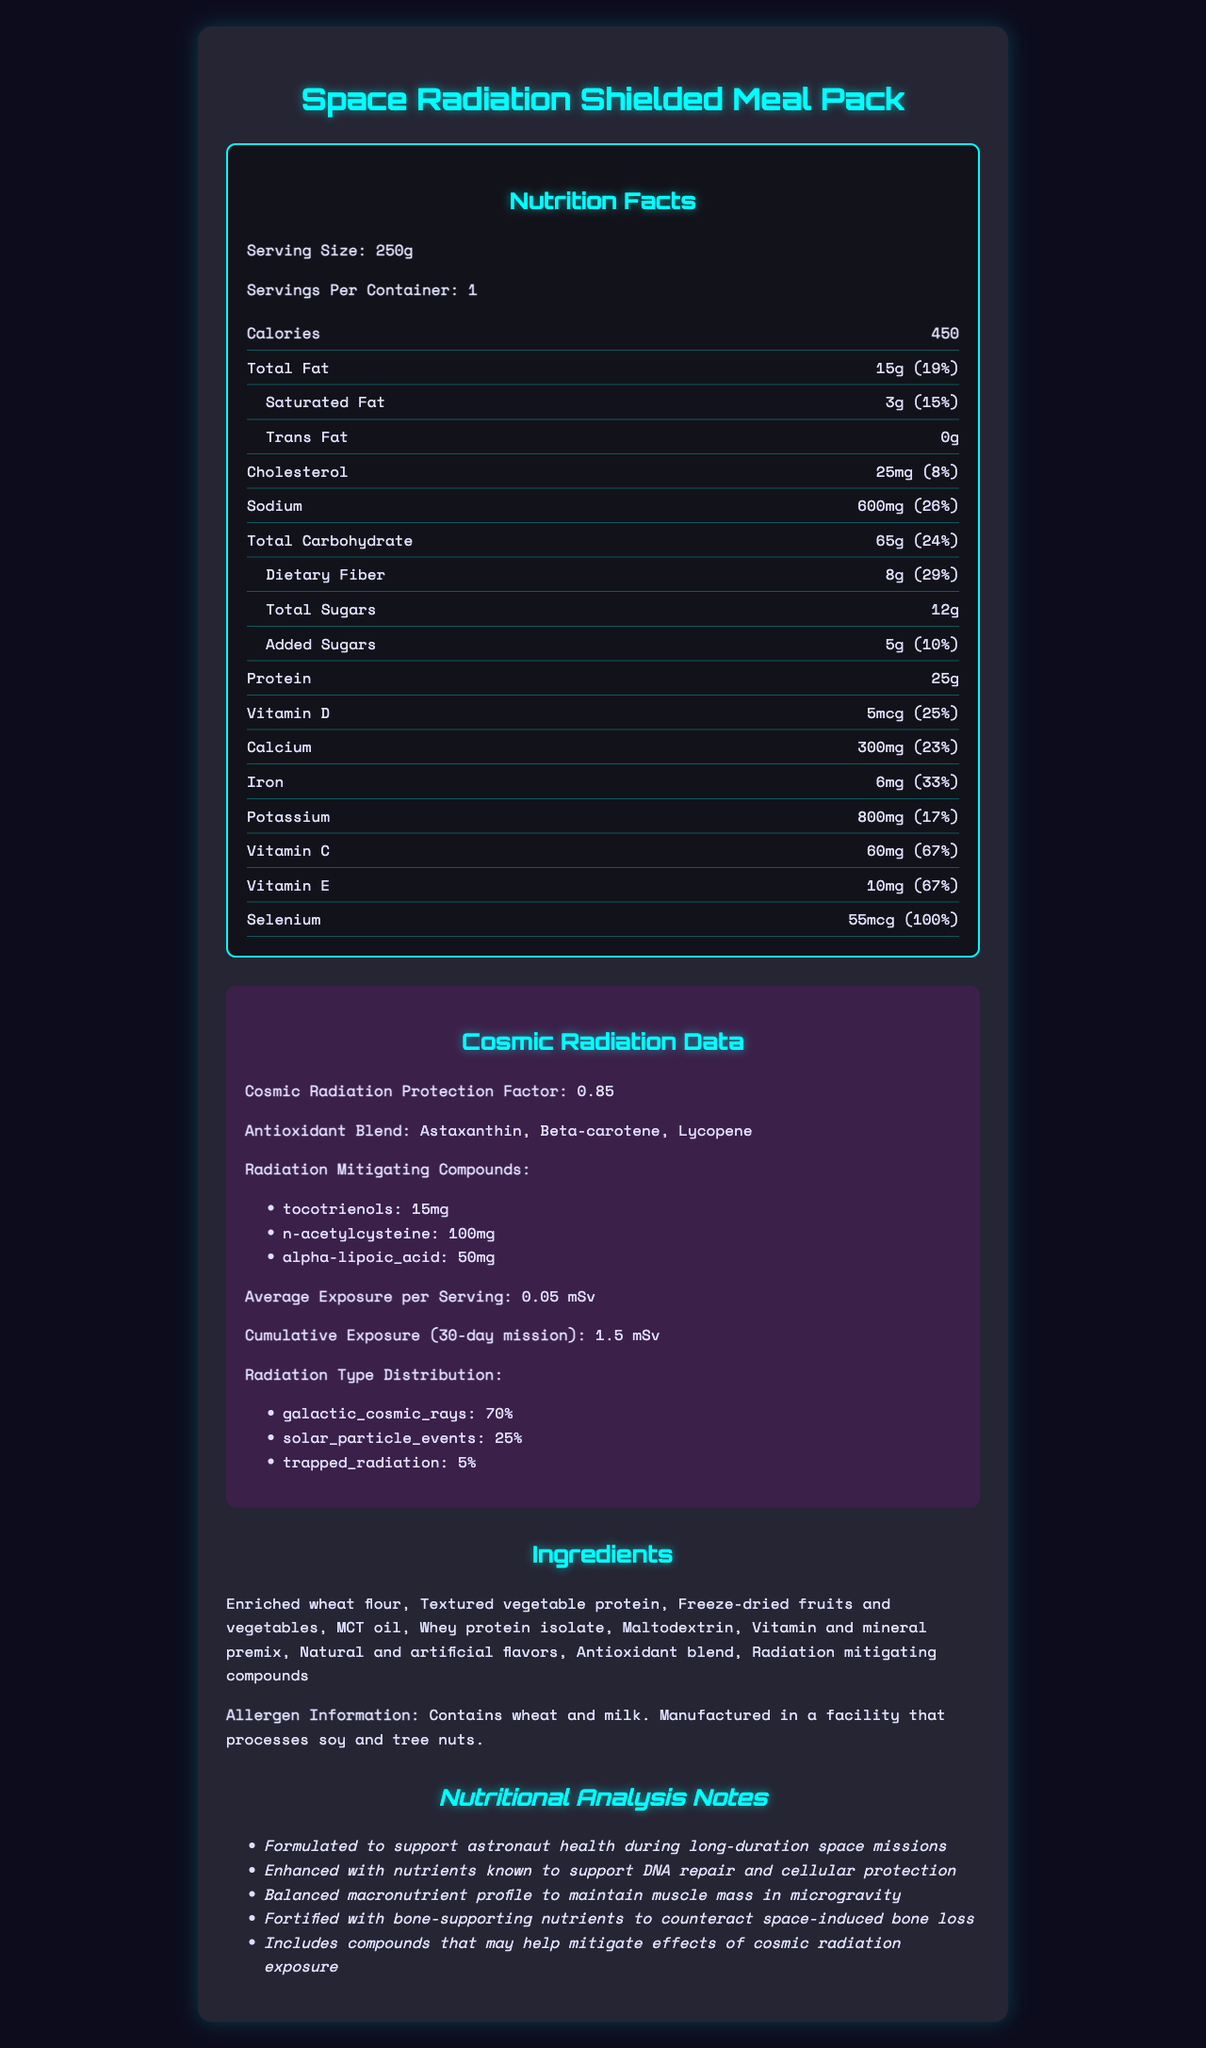what is the serving size? The serving size is listed as "250g" under the nutrition facts section.
Answer: 250g how many servings are in one container? The document states "Servings Per Container: 1."
Answer: 1 what is the total fat content per serving? The document lists "Total Fat" as "15g" under the nutrition facts section.
Answer: 15g what percentage of the daily value of saturated fat does one serving provide? The document states "Saturated Fat: 3g (15%)" under the nutrition facts section.
Answer: 15% how much dietary fiber is in one serving? The amount of dietary fiber per serving is listed as "8g" in the nutrition facts.
Answer: 8g what are the antioxidant compounds in the meal pack? The document lists the antioxidants under the "Antioxidant Blend" section as "Astaxanthin, Beta-carotene, Lycopene."
Answer: Astaxanthin, Beta-carotene, Lycopene how much protein is in one serving? The amount of protein per serving is shown as "25g" in the nutrition facts.
Answer: 25g what is the cosmic radiation protection factor of the meal pack? The cosmic radiation protection factor is listed as "0.85."
Answer: 0.85 what is the shelf life of the Space Radiation Shielded Meal Pack? The shelf life is mentioned as "5 years" in the document.
Answer: 5 years which is NOT one of the radiation-mitigating compounds in the meal pack? A. Tocotrienols B. Resveratrol C. N-acetylcysteine D. Alpha-lipoic acid The document lists the radiation-mitigating compounds as "Tocotrienols, N-acetylcysteine, Alpha-lipoic acid." Resveratrol is not listed.
Answer: B what is the main type of radiation the meal pack is exposed to? A. Galactic Cosmic Rays B. Solar Particle Events C. Trapped Radiation D. X-rays The document indicates "Galactic Cosmic Rays" as 70%, which is the highest percentage among the radiation types listed.
Answer: A is sodium content in one serving higher than 20% of the daily value? The document shows sodium content as "600mg (26%)," which is higher than 20% of the daily value.
Answer: Yes describe the main idea of the document The document presents a comprehensive assessment of the meal pack's nutritional profile, aimed at supporting astronaut health and mitigating cosmic radiation effects during long-duration space missions.
Answer: The document provides detailed nutritional information for the "Space Radiation Shielded Meal Pack," highlighting its macronutrient content, vitamins, minerals, and ingredients. It includes special features like cosmic radiation protection, antioxidant blends, and radiation-mitigating compounds. The document also covers storage instructions, shelf life, and cosmic radiation exposure data relevant to long-duration space missions. what is the specific amount of trans fat per serving? The document specifies that the trans fat content is "0g."
Answer: 0g how much potassium is in one serving? The potassium content is listed as "800mg" in the nutrition facts section.
Answer: 800mg how many mcg of selenium does one serving contain? The document states selenium content as "55mcg."
Answer: 55mcg how much average cosmic radiation exposure per serving is there? The document indicates "Average Exposure per Serving: 0.05 mSv."
Answer: 0.05 mSv what nutrients are enhanced to support DNA repair and cellular protection? The document states these nutrients are enhanced but does not specify which ones in the nutritional analysis notes. Therefore, it cannot be determined from the given information.
Answer: Cannot be determined 